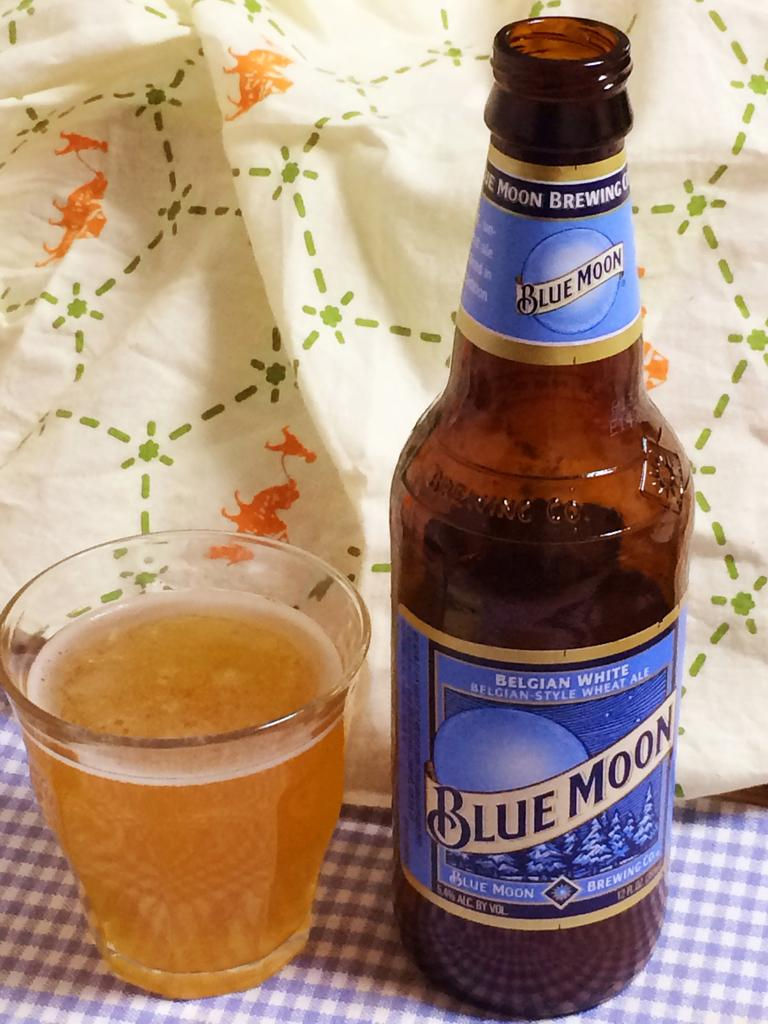<image>
Render a clear and concise summary of the photo. A bottle of Blue Moon beer describes itself as Belgian-style wheat ale. 